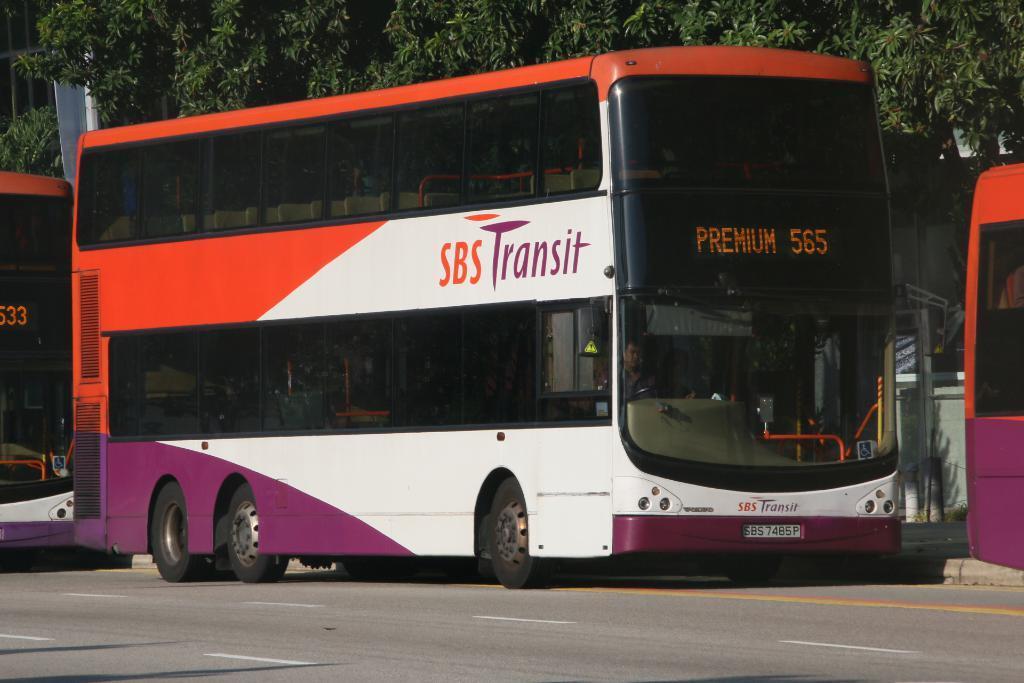Describe this image in one or two sentences. In the foreground of this image, there is a bus on the road. On either side, there are truncated buses. At the top, there are trees. 